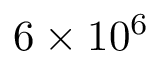Convert formula to latex. <formula><loc_0><loc_0><loc_500><loc_500>6 \times 1 0 ^ { 6 }</formula> 